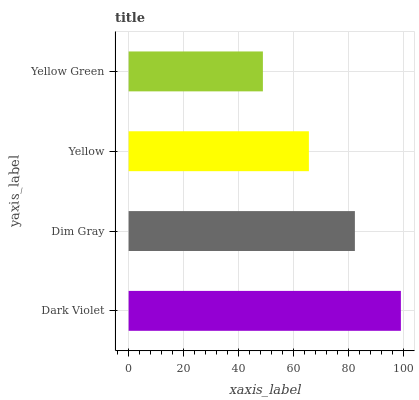Is Yellow Green the minimum?
Answer yes or no. Yes. Is Dark Violet the maximum?
Answer yes or no. Yes. Is Dim Gray the minimum?
Answer yes or no. No. Is Dim Gray the maximum?
Answer yes or no. No. Is Dark Violet greater than Dim Gray?
Answer yes or no. Yes. Is Dim Gray less than Dark Violet?
Answer yes or no. Yes. Is Dim Gray greater than Dark Violet?
Answer yes or no. No. Is Dark Violet less than Dim Gray?
Answer yes or no. No. Is Dim Gray the high median?
Answer yes or no. Yes. Is Yellow the low median?
Answer yes or no. Yes. Is Yellow the high median?
Answer yes or no. No. Is Dim Gray the low median?
Answer yes or no. No. 